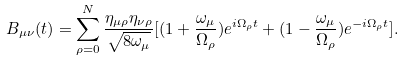Convert formula to latex. <formula><loc_0><loc_0><loc_500><loc_500>B _ { \mu \nu } ( t ) = \sum _ { \rho = 0 } ^ { N } \frac { \eta _ { \mu \rho } \eta _ { \nu \rho } } { \sqrt { 8 \omega _ { \mu } } } [ ( 1 + \frac { \omega _ { \mu } } { \Omega _ { \rho } } ) e ^ { i \Omega _ { \rho } t } + ( 1 - \frac { \omega _ { \mu } } { \Omega _ { \rho } } ) e ^ { - i \Omega _ { \rho } t } ] .</formula> 